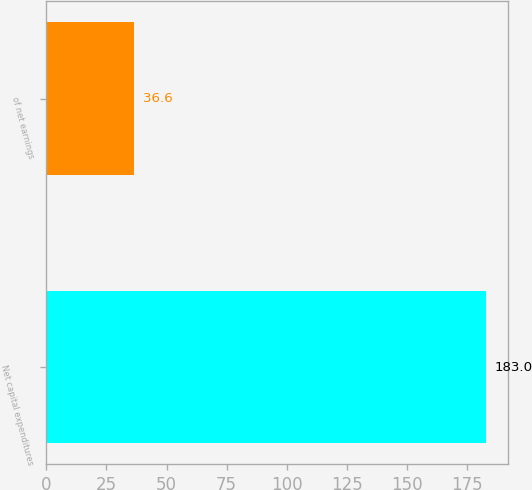<chart> <loc_0><loc_0><loc_500><loc_500><bar_chart><fcel>Net capital expenditures<fcel>of net earnings<nl><fcel>183<fcel>36.6<nl></chart> 